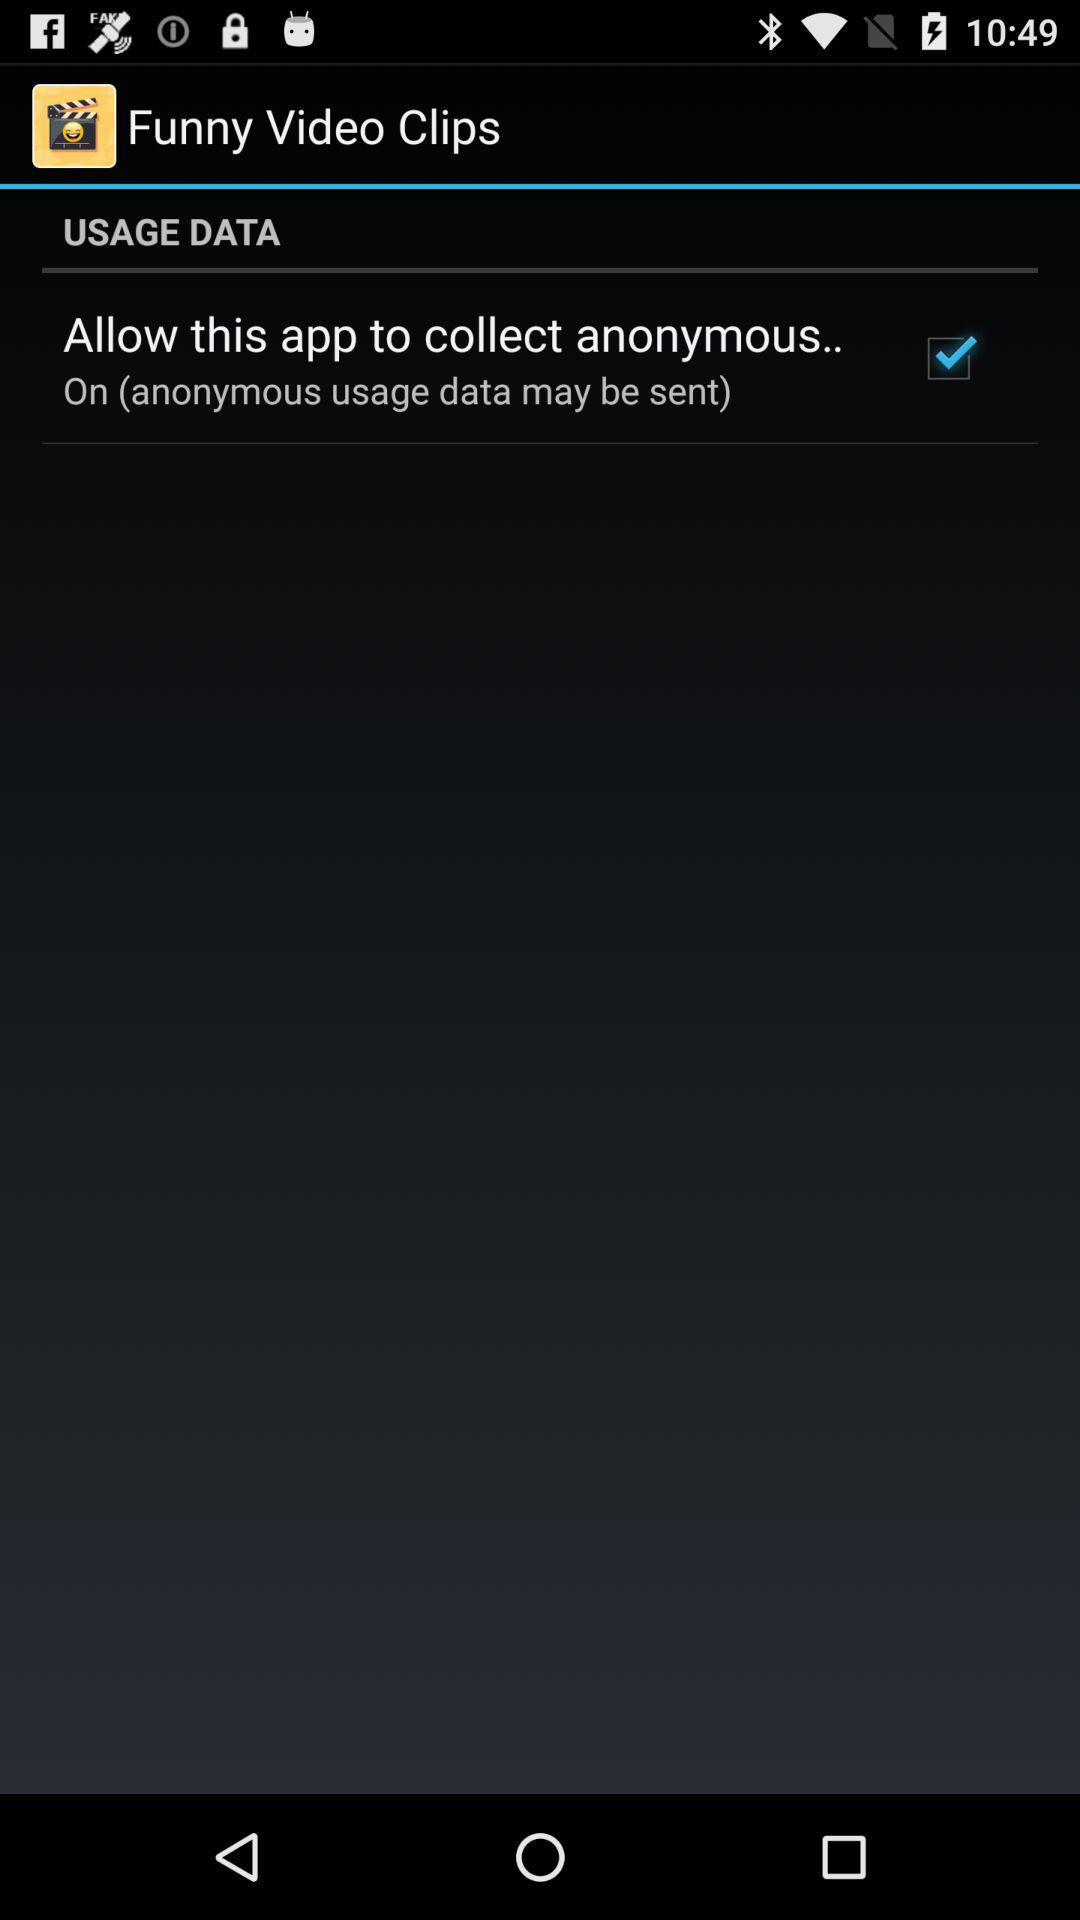What option is checked? The checked option is "Allow this app to collect anonymous..". 